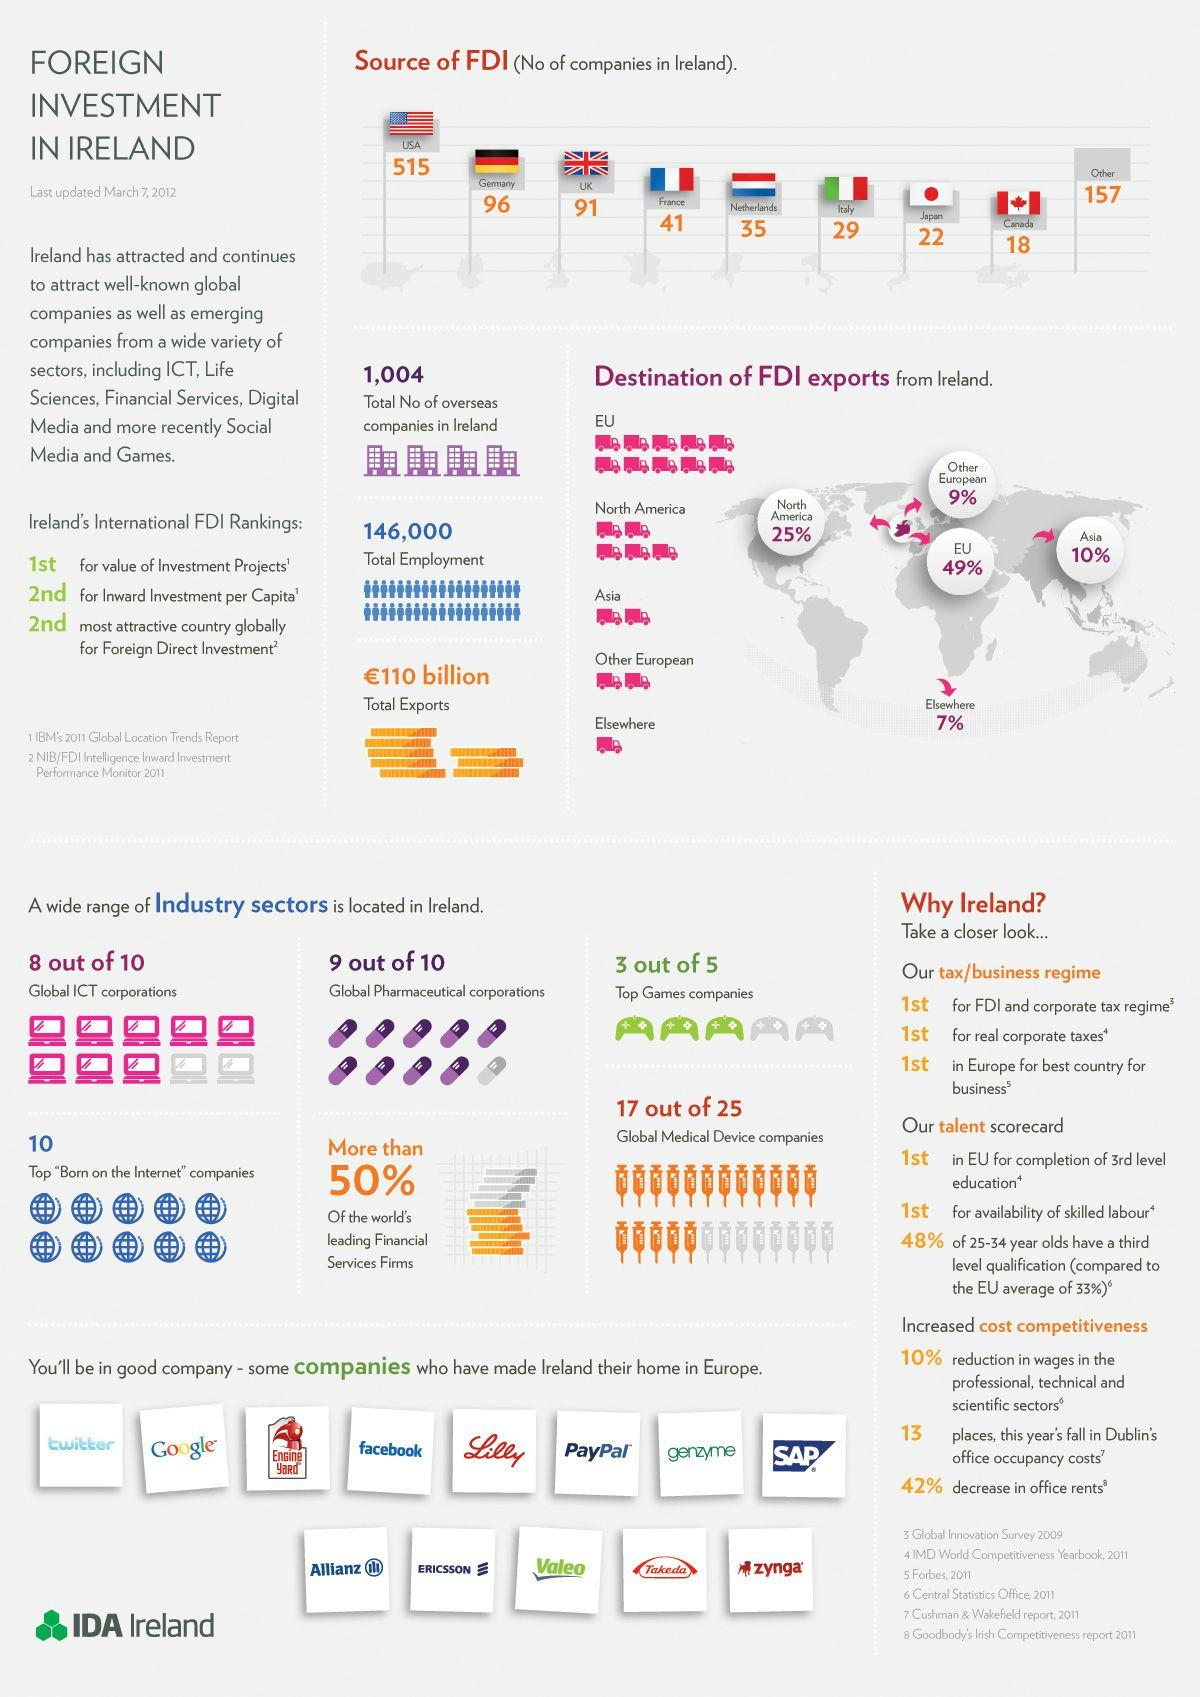List a handful of essential elements in this visual. The combined Foreign Direct Investment from the United States and Japan is 537. Ireland is the second country in terms of inward investment per capita. The total amount of foreign direct investment from other countries is 157. The Foreign Direct Investment from the Netherlands amounted to 35.. The area with the second highest amount of FDI exports from Ireland is North America. 